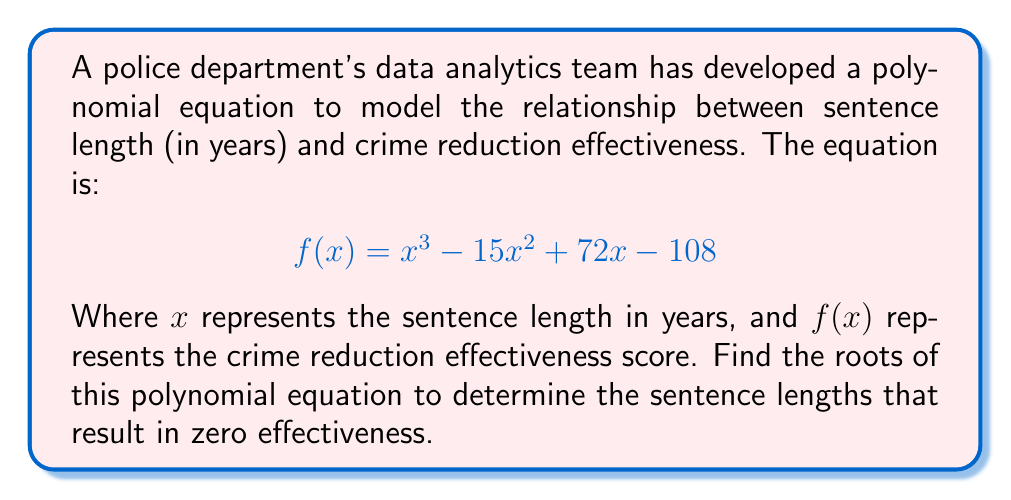Solve this math problem. To find the roots of this polynomial equation, we need to factor the cubic equation:

1) First, let's check if there's a rational root using the rational root theorem. Possible rational roots are factors of the constant term: ±1, ±2, ±3, ±4, ±6, ±9, ±12, ±18, ±27, ±36, ±54, ±108.

2) Testing these, we find that $x = 6$ is a root. So $(x - 6)$ is a factor.

3) Divide the polynomial by $(x - 6)$:

   $$(x^3 - 15x^2 + 72x - 108) \div (x - 6) = x^2 - 9x + 18$$

4) The remaining quadratic equation is $x^2 - 9x + 18 = 0$

5) We can solve this using the quadratic formula: $x = \frac{-b \pm \sqrt{b^2 - 4ac}}{2a}$

   Where $a = 1$, $b = -9$, and $c = 18$

6) Substituting:

   $$x = \frac{9 \pm \sqrt{81 - 72}}{2} = \frac{9 \pm 3}{2}$$

7) This gives us two more roots:

   $$x = \frac{9 + 3}{2} = 6$$ and $$x = \frac{9 - 3}{2} = 3$$

Therefore, the roots of the polynomial are 3 and 6 (with 6 being a double root).
Answer: $x = 3$ or $x = 6$ 